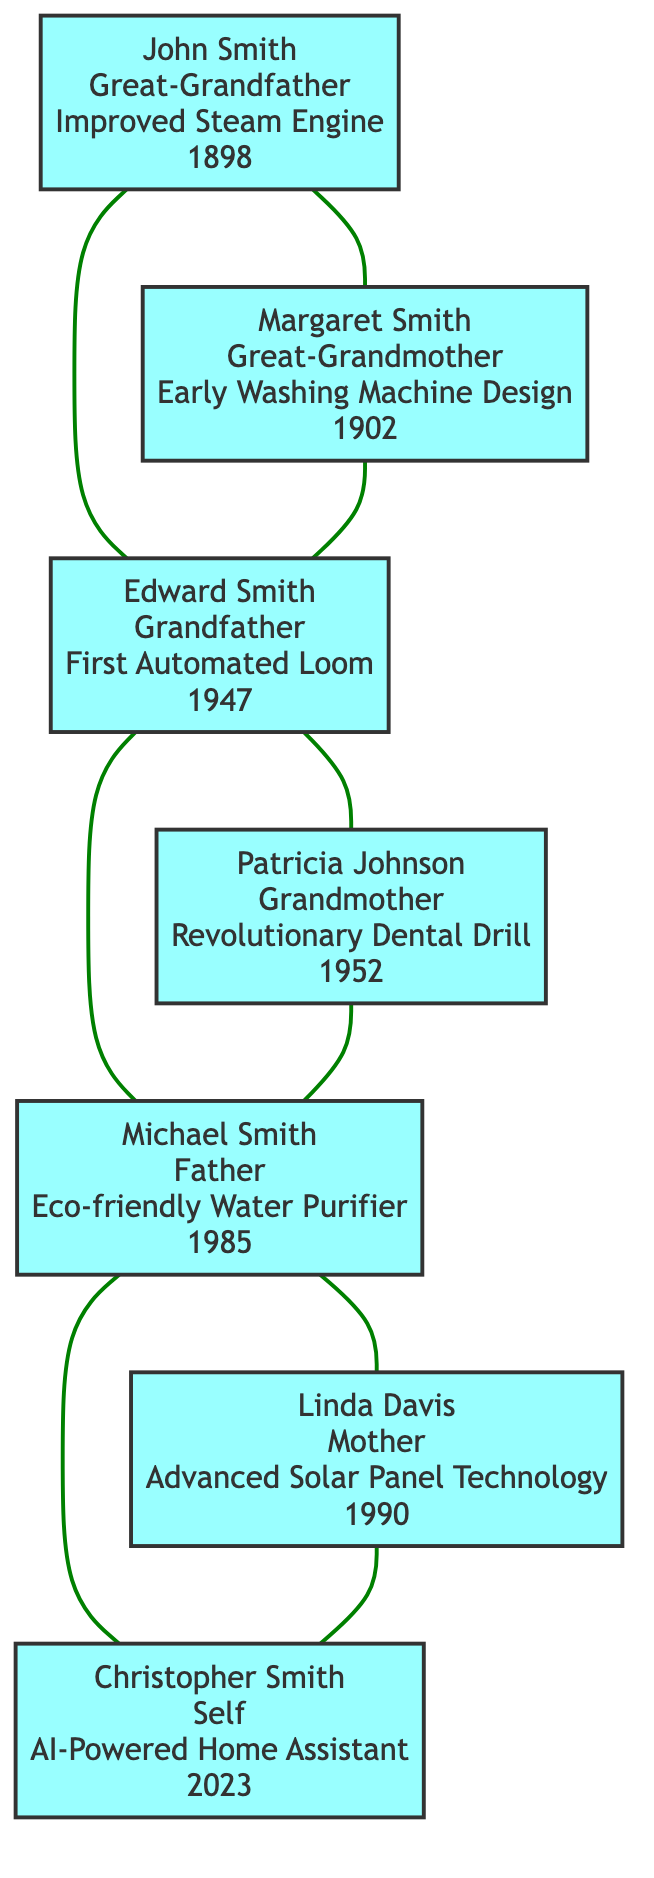What is the innovation of Patricia Johnson? The diagram shows that Patricia Johnson, who is the Grandmother, has the innovation labeled as "Revolutionary Dental Drill".
Answer: Revolutionary Dental Drill Who is the Father in this family tree? In the diagram, the Father is represented as Michael Smith connecting directly under the Grandfather and Grandmother.
Answer: Michael Smith What year did Margaret Smith introduce her design? The diagram indicates that Margaret Smith, the Great-Grandmother, introduced her work, "Early Washing Machine Design", in the year 1902.
Answer: 1902 How many generations are represented in the family tree? The diagram shows four distinct generations: Great-Grandparents, Grandparents, Parents, and Self, totaling to four generations.
Answer: 4 What innovation did Christopher Smith create? According to the diagram, Christopher Smith, identified as "Self", created the innovation "AI-Powered Home Assistant".
Answer: AI-Powered Home Assistant Which innovation came after the First Automated Loom? The diagram shows that after Edward Smith's innovation of the "First Automated Loom" in 1947, the next innovation listed is "Revolutionary Dental Drill" by Patricia Johnson in 1952.
Answer: Revolutionary Dental Drill Who are the two Great-Grandparents listed? The diagram displays that the two Great-Grandparents are John Smith and Margaret Smith, positioned at the top of the family tree.
Answer: John Smith and Margaret Smith How is Linda Davis related to Christopher Smith? The diagram illustrates that Linda Davis is Christopher Smith's Mother, establishing a direct lineage from Mother to Self.
Answer: Mother What is the earliest innovation in the family tree? The diagram indicates that the earliest innovation listed is "Improved Steam Engine" by John Smith in the year 1898.
Answer: Improved Steam Engine 